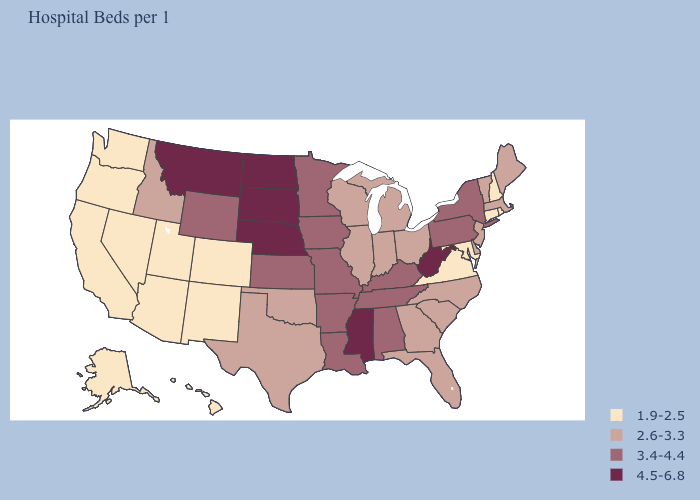Is the legend a continuous bar?
Keep it brief. No. Among the states that border Minnesota , does North Dakota have the highest value?
Give a very brief answer. Yes. Does the first symbol in the legend represent the smallest category?
Concise answer only. Yes. Among the states that border Illinois , does Wisconsin have the lowest value?
Keep it brief. Yes. Is the legend a continuous bar?
Quick response, please. No. Among the states that border Ohio , does West Virginia have the highest value?
Write a very short answer. Yes. Does Florida have a higher value than Utah?
Quick response, please. Yes. Does Alabama have the lowest value in the South?
Quick response, please. No. What is the lowest value in states that border South Dakota?
Answer briefly. 3.4-4.4. How many symbols are there in the legend?
Concise answer only. 4. Among the states that border Iowa , which have the highest value?
Be succinct. Nebraska, South Dakota. Which states hav the highest value in the West?
Keep it brief. Montana. Name the states that have a value in the range 3.4-4.4?
Answer briefly. Alabama, Arkansas, Iowa, Kansas, Kentucky, Louisiana, Minnesota, Missouri, New York, Pennsylvania, Tennessee, Wyoming. Which states have the highest value in the USA?
Keep it brief. Mississippi, Montana, Nebraska, North Dakota, South Dakota, West Virginia. What is the lowest value in the Northeast?
Short answer required. 1.9-2.5. 